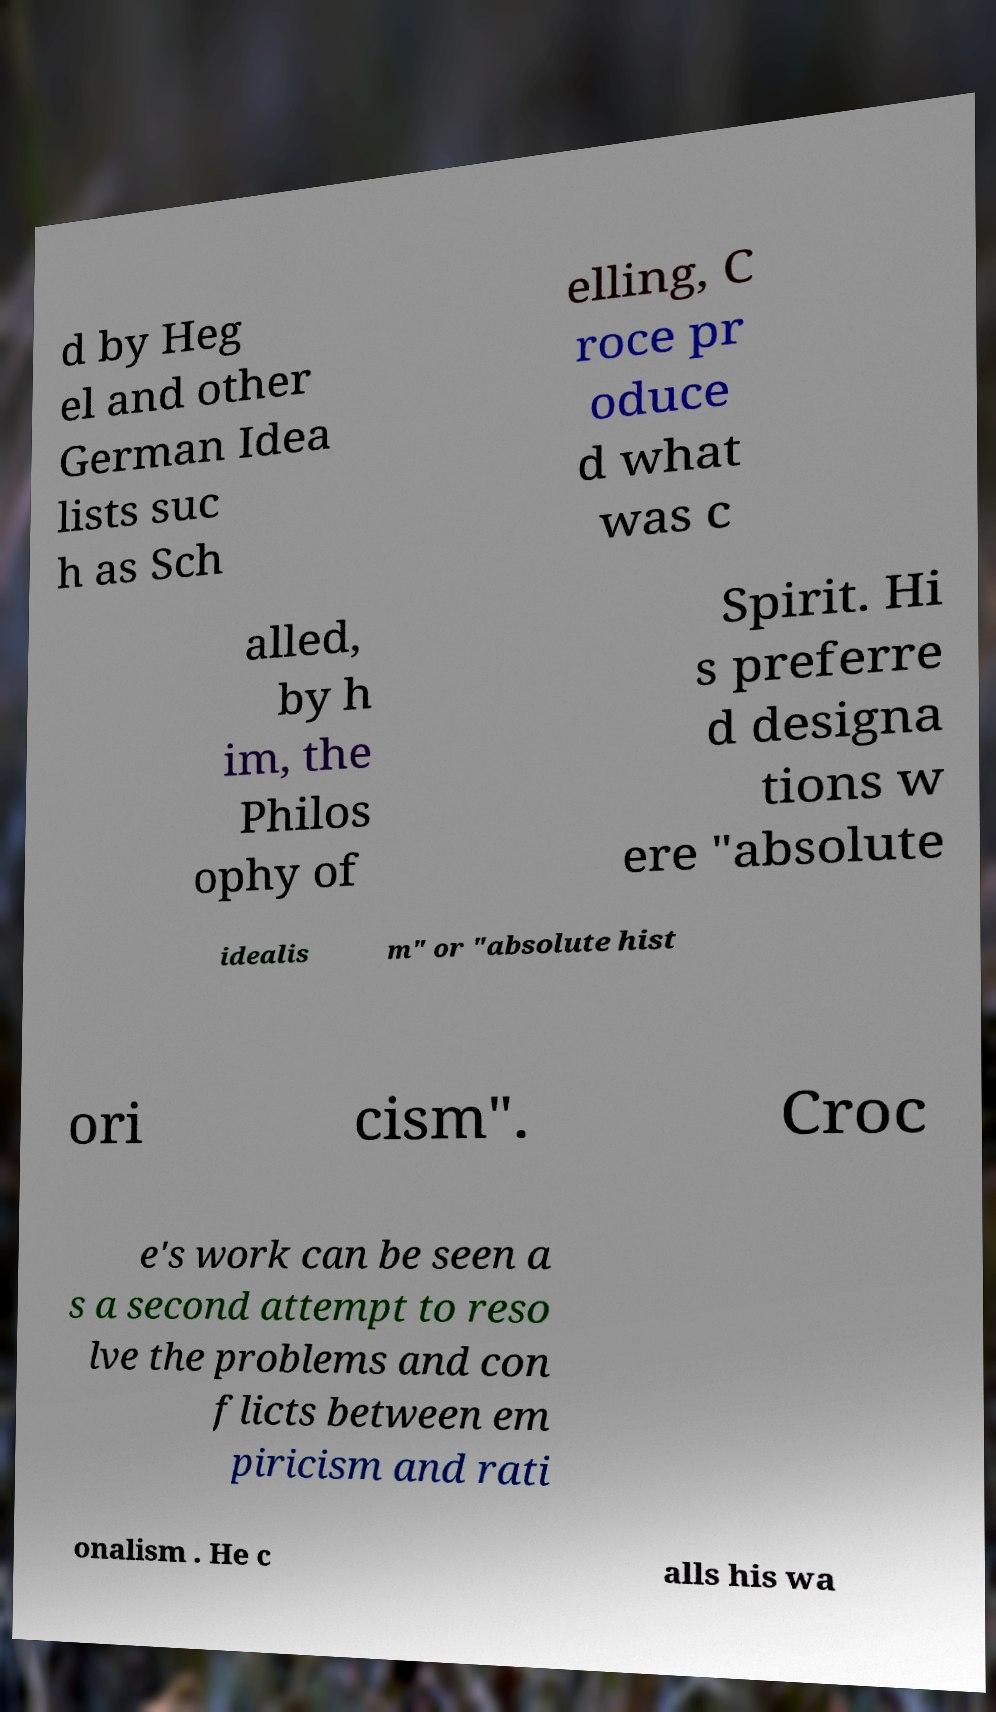Please read and relay the text visible in this image. What does it say? d by Heg el and other German Idea lists suc h as Sch elling, C roce pr oduce d what was c alled, by h im, the Philos ophy of Spirit. Hi s preferre d designa tions w ere "absolute idealis m" or "absolute hist ori cism". Croc e's work can be seen a s a second attempt to reso lve the problems and con flicts between em piricism and rati onalism . He c alls his wa 